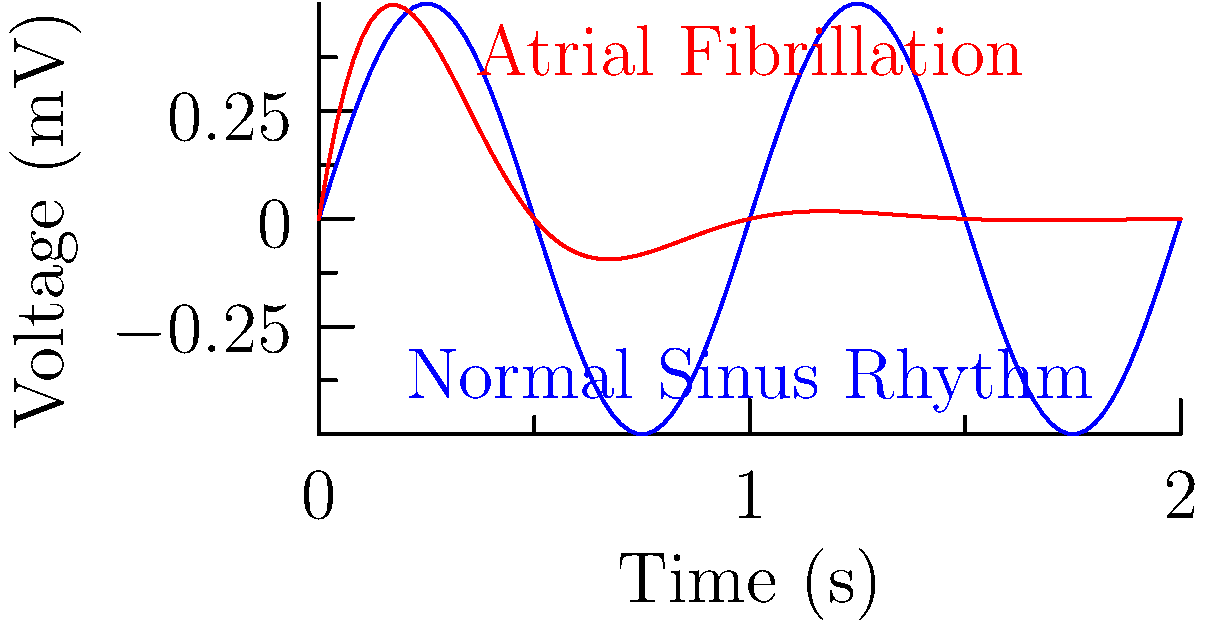An ECG waveform for a patient with atrial fibrillation can be modeled by the function $f(t) = Ae^{-t/\tau}\sin(2\pi ft)$, where $A$ is the amplitude, $\tau$ is the decay constant, and $f$ is the frequency. If the amplitude is 0.5 mV, the decay constant is 0.3 seconds, and the frequency is 1 Hz, what is the maximum rate of change of the ECG voltage (in mV/s) within the first second? To find the maximum rate of change, we need to follow these steps:

1) The given function is $f(t) = 0.5e^{-t/0.3}\sin(2\pi t)$

2) To find the rate of change, we need to differentiate this function:

   $f'(t) = 0.5e^{-t/0.3}[2\pi \cos(2\pi t)] + 0.5\sin(2\pi t)[-\frac{1}{0.3}e^{-t/0.3}]$

3) Simplify:

   $f'(t) = 0.5e^{-t/0.3}[2\pi \cos(2\pi t) - \frac{1}{0.3}\sin(2\pi t)]$

4) The maximum rate of change will occur when this derivative function reaches its maximum absolute value. Due to the complexity of this function, we can't solve for this analytically, so we'll evaluate the function at several points in the first second.

5) Let's evaluate at t = 0, 0.25, 0.5, 0.75, and 1:

   At t = 0: $f'(0) = 0.5[2\pi] = \pi \approx 3.14$
   At t = 0.25: $f'(0.25) \approx 2.91$
   At t = 0.5: $f'(0.5) \approx -2.53$
   At t = 0.75: $f'(0.75) \approx -2.20$
   At t = 1: $f'(1) \approx 1.69$

6) The maximum absolute value among these is approximately 3.14 mV/s, which occurs at t = 0.
Answer: $\pi$ mV/s or approximately 3.14 mV/s 